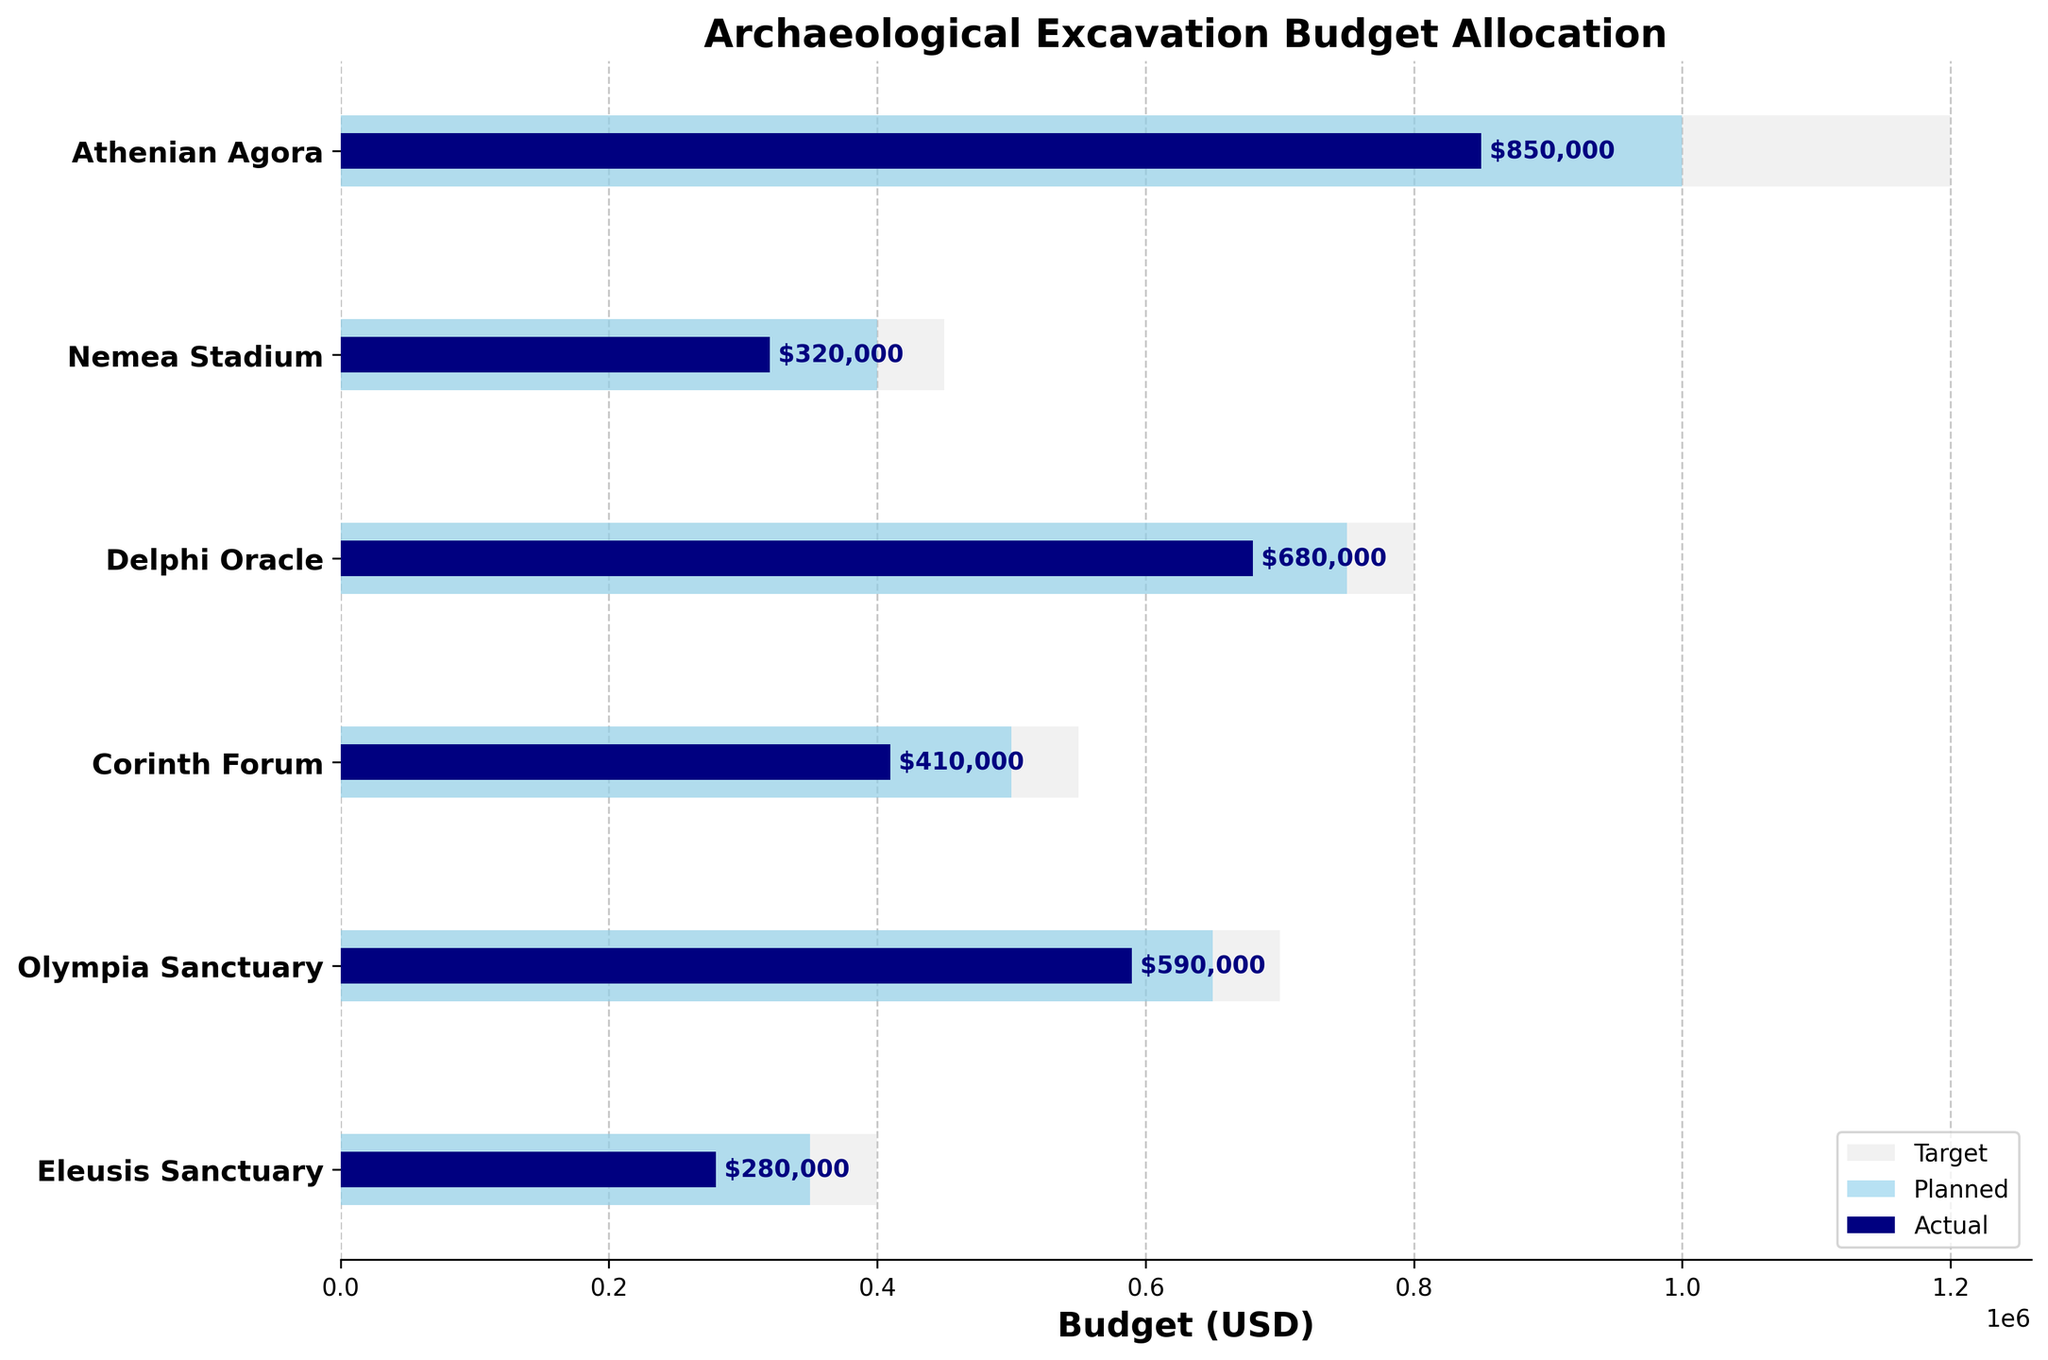What is the title of the figure? The title of the figure is located at the top and gives an overview of what the chart represents. In this case, the title reads "Archaeological Excavation Budget Allocation".
Answer: Archaeological Excavation Budget Allocation Which category has the highest actual budget allocation? The category with the highest actual budget allocation will have the longest bar in the 'Actual' category. In this case, it's the 'Athenian Agora' with $850,000.
Answer: Athenian Agora What is the planned budget for the Olympia Sanctuary? The planned budget for a category is the second bar from the left within that category row. For 'Olympia Sanctuary', the planned budget is $650,000.
Answer: $650,000 How much more is the planned budget than the actual budget for Delphi Oracle? To find the difference between the planned and actual budget for Delphi Oracle, subtract the actual budget from the planned budget: $750,000 - $680,000 = $70,000.
Answer: $70,000 What is the average target budget across all categories? To find the average target budget, sum all the target budgets ($1,200,000 + $450,000 + $800,000 + $550,000 + $700,000 + $400,000) and divide by the number of categories (6). This totals to $4,100,000 / 6 = $683,333.33.
Answer: $683,333.33 Which category has the smallest difference between its planned and actual budget? Calculate the differences between planned and actual budgets for each category and identify the smallest one: Olympia Sanctuary ($650,000 - $590,000 = $60,000), Nemea Stadium ($400,000 - $320,000 = $80,000), Delphi Oracle ($750,000 - $680,000 = $70,000), Athenian Agora ($1,000,000 - $850,000 = $150,000), Corinth Forum ($500,000 - $410,000 = $90,000), Eleusis Sanctuary ($350,000 - $280,000 = $70,000). The smallest difference is for Olympia Sanctuary at $60,000.
Answer: Olympia Sanctuary Which categories have an actual budget greater than 50% of their target budget? For each category, calculate 50% of the target budget and check if the actual budget exceeds this value. Results are: Athenian Agora ($1,200,000 * 0.5 = $600,000 < $850,000), Nemea Stadium ($450,000 * 0.5 = $225,000 < $320,000), Delphi Oracle ($800,000 * 0.5 = $400,000 < $680,000), Corinth Forum ($550,000 * 0.5 = $275,000 < $410,000), Olympia Sanctuary ($700,000 * 0.5 = $350,000 < $590,000), Eleusis Sanctuary ($400,000 * 0.5 = $200,000 < $280,000). All categories meet this condition.
Answer: Athenian Agora, Nemea Stadium, Delphi Oracle, Corinth Forum, Olympia Sanctuary, Eleusis Sanctuary How much in total has been actually spent across all categories? Sum the actual budgets of all categories: $850,000 + $320,000 + $680,000 + $410,000 + $590,000 + $280,000 = $3,130,000.
Answer: $3,130,000 Which category is closest to meeting its target budget based on actual expenditure? Calculate the percentage of the target budget met by the actual expenditure for each category. Closest to 100% (maximum value) will be: Athenian Agora ($850,000 / $1,200,000 = 70.83%), Nemea Stadium ($320,000 / $450,000 = 71.11%), Delphi Oracle ($680,000 / $800,000 = 85%), Corinth Forum ($410,000 / $550,000 = 74.55%), Olympia Sanctuary ($590,000 / $700,000 = 84.29%), Eleusis Sanctuary ($280,000 / $400,000 = 70%). The Delphi Oracle is the closest at 85%.
Answer: Delphi Oracle 